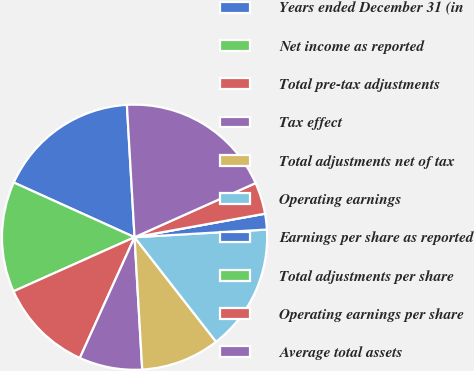Convert chart to OTSL. <chart><loc_0><loc_0><loc_500><loc_500><pie_chart><fcel>Years ended December 31 (in<fcel>Net income as reported<fcel>Total pre-tax adjustments<fcel>Tax effect<fcel>Total adjustments net of tax<fcel>Operating earnings<fcel>Earnings per share as reported<fcel>Total adjustments per share<fcel>Operating earnings per share<fcel>Average total assets<nl><fcel>17.31%<fcel>13.46%<fcel>11.54%<fcel>7.69%<fcel>9.62%<fcel>15.38%<fcel>1.92%<fcel>0.0%<fcel>3.85%<fcel>19.23%<nl></chart> 